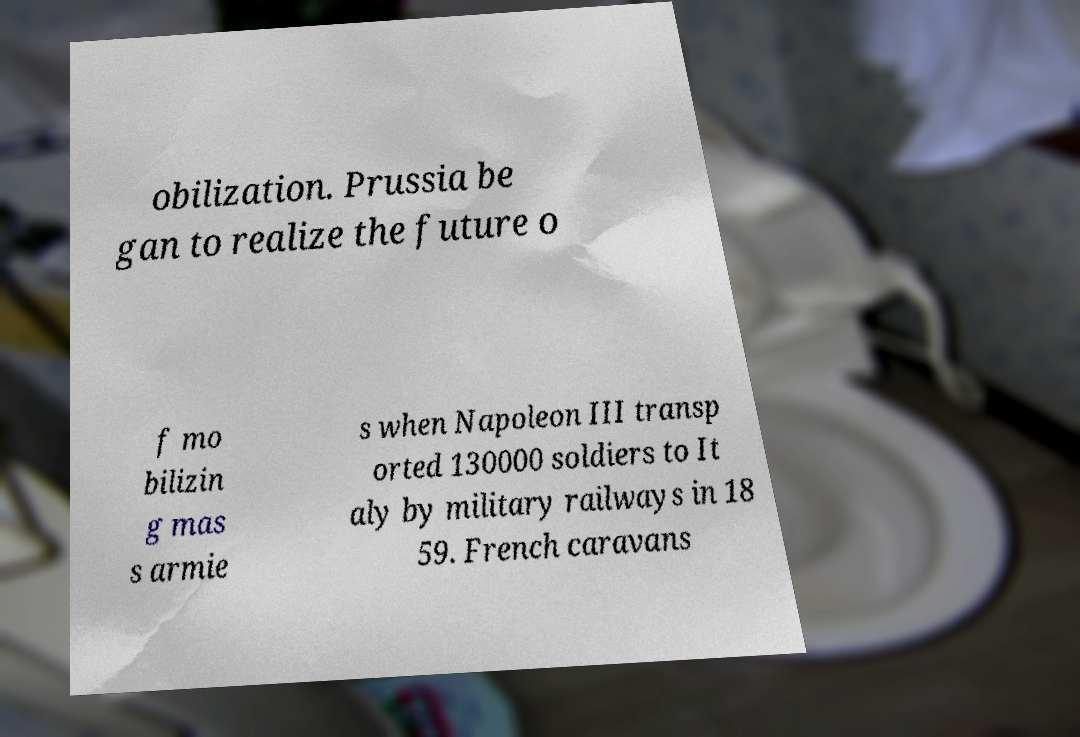Could you extract and type out the text from this image? obilization. Prussia be gan to realize the future o f mo bilizin g mas s armie s when Napoleon III transp orted 130000 soldiers to It aly by military railways in 18 59. French caravans 